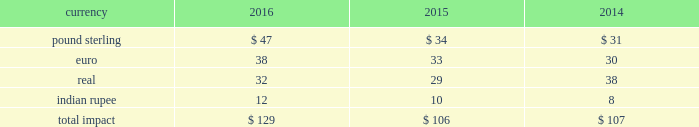Changes in the benchmark index component of the 10-year treasury yield .
The company def signated these derivatives as cash flow hedges .
On october 13 , 2015 , in conjunction with the pricing of the $ 4.5 billion senior notes , the companyr terminated these treasury lock contracts for a cash settlement payment of $ 16 million , which was recorded as a component of other comprehensive earnings and will be reclassified as an adjustment to interest expense over the ten years during which the related interest payments that were hedged will be recognized in income .
Foreign currency risk we are exposed to foreign currency risks that arise from normal business operations .
These risks include the translation of local currency balances of foreign subsidiaries , transaction gains and losses associated with intercompany loans with foreign subsidiaries and transactions denominated in currencies other than a location's functional currency .
We manage the exposure to these risks through a combination of normal operating activities and the use of foreign currency forward contracts .
Contracts are denominated in currtt encies of major industrial countries .
Our exposure to foreign currency exchange risks generally arises from our non-u.s .
Operations , to the extent they are conducted ind local currency .
Changes in foreign currency exchange rates affect translations of revenues denominated in currencies other than the u.s .
Dollar .
During the years ended december 31 , 2016 , 2015 and 2014 , we generated approximately $ 1909 million , $ 1336 million and $ 1229 million , respectively , in revenues denominated in currencies other than the u.s .
Dollar .
The major currencies to which our revenues are exposed are the brazilian real , the euro , the british pound sterling and the indian rupee .
A 10% ( 10 % ) move in average exchange rates for these currencies ( assuming a simultaneous and immediate 10% ( 10 % ) change in all of such rates for the relevant period ) would have resulted in the following increase or ( decrease ) in our reported revenues for the years ended december 31 , 2016 , 2015 and 2014 ( in millions ) : .
While our results of operations have been impacted by the effects of currency fluctuations , our international operations' revenues and expenses are generally denominated in local currency , which reduces our economic exposure to foreign exchange risk in those jurisdictions .
Revenues included $ 100 million and $ 243 million and net earnings included $ 10 million , anrr d $ 31 million , respectively , of unfavorable foreign currency impact during 2016 and 2015 resulting from a stronger u.s .
Dollar during these years compared to thet preceding year .
In 2017 , we expect continued unfavorable foreign currency impact on our operating income resulting from the continued strengthening of the u.s .
Dollar vs .
Other currencies .
Our foreign exchange risk management policy permits the use of derivative instruments , such as forward contracts and options , to reduce volatility in our results of operations and/or cash flows resulting from foreign exchange rate fluctuations .
We do not enter into foreign currency derivative instruments for trading purposes or to engage in speculative activitr y .
We do periodically enter inttt o foreign currency forward exchange contracts to hedge foreign currency exposure to intercompany loans .
As of december 31 , 2016 , the notional amount of these derivatives was approximately $ 143 million and the fair value was nominal .
These derivatives are intended to hedge the foreign exchange risks related to intercompany loans but have not been designated as hedges for accounting purposes .
We also use currency forward contracts to manage our exposure to fluctuations in costs caused by variations in indian rupee ( "inr" ) exchange rates .
As of december 31 , 2016 , the notional amount of these derivatives was approximately $ 7 million and the fair value was ll less than $ 1 million .
These inr forward contracts are designated as cash flow hedges .
The fair value of these currency forward contracts is determined using currency exchange market rates , obtained from reliable , independent , third m party banks , at the balance sheet date .
The fair value of forward contracts is subject to changes in currency exchange rates .
The company has no ineffectiveness related to its use of currency forward contracts in connection with inr cash flow hedges .
In conjunction with entering into the definitive agreement to acquire clear2pay in september 2014 , we initiated a foreign currency forward contract to purchase euros and sell u.s .
Dollars to manage the risk arising from fluctuations in exchange rates until the closing because the purchase price was stated in euros .
As this derivative did not qualify for hedge accounting , we recorded a charge of $ 16 million in other income ( expense ) , net during the third quarter of 2014 .
This forward contract was settled on october 1 , 2014. .
What was the difference in total impact between 2015 and 2016 , in millions? 
Computations: (129 - 106)
Answer: 23.0. 